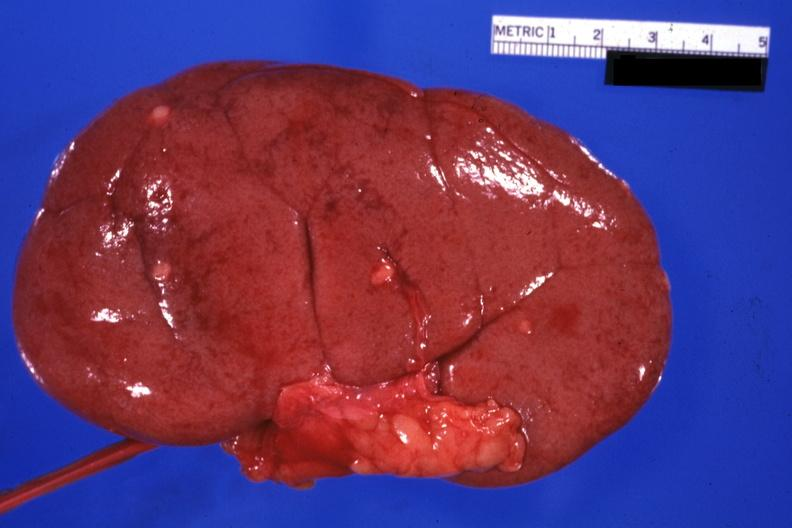what is external view with capsule removed?
Answer the question using a single word or phrase. Small lesions easily seen 